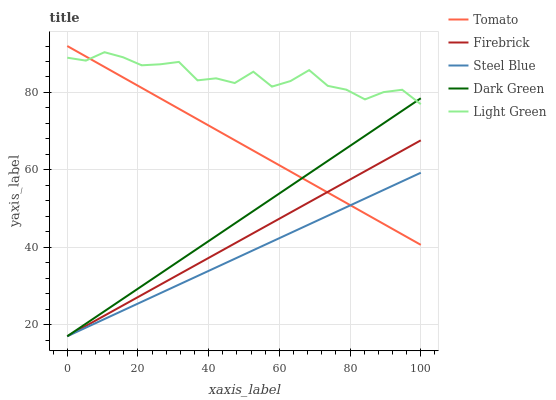Does Steel Blue have the minimum area under the curve?
Answer yes or no. Yes. Does Light Green have the maximum area under the curve?
Answer yes or no. Yes. Does Firebrick have the minimum area under the curve?
Answer yes or no. No. Does Firebrick have the maximum area under the curve?
Answer yes or no. No. Is Dark Green the smoothest?
Answer yes or no. Yes. Is Light Green the roughest?
Answer yes or no. Yes. Is Firebrick the smoothest?
Answer yes or no. No. Is Firebrick the roughest?
Answer yes or no. No. Does Firebrick have the lowest value?
Answer yes or no. Yes. Does Light Green have the lowest value?
Answer yes or no. No. Does Tomato have the highest value?
Answer yes or no. Yes. Does Firebrick have the highest value?
Answer yes or no. No. Is Firebrick less than Light Green?
Answer yes or no. Yes. Is Light Green greater than Steel Blue?
Answer yes or no. Yes. Does Dark Green intersect Tomato?
Answer yes or no. Yes. Is Dark Green less than Tomato?
Answer yes or no. No. Is Dark Green greater than Tomato?
Answer yes or no. No. Does Firebrick intersect Light Green?
Answer yes or no. No. 